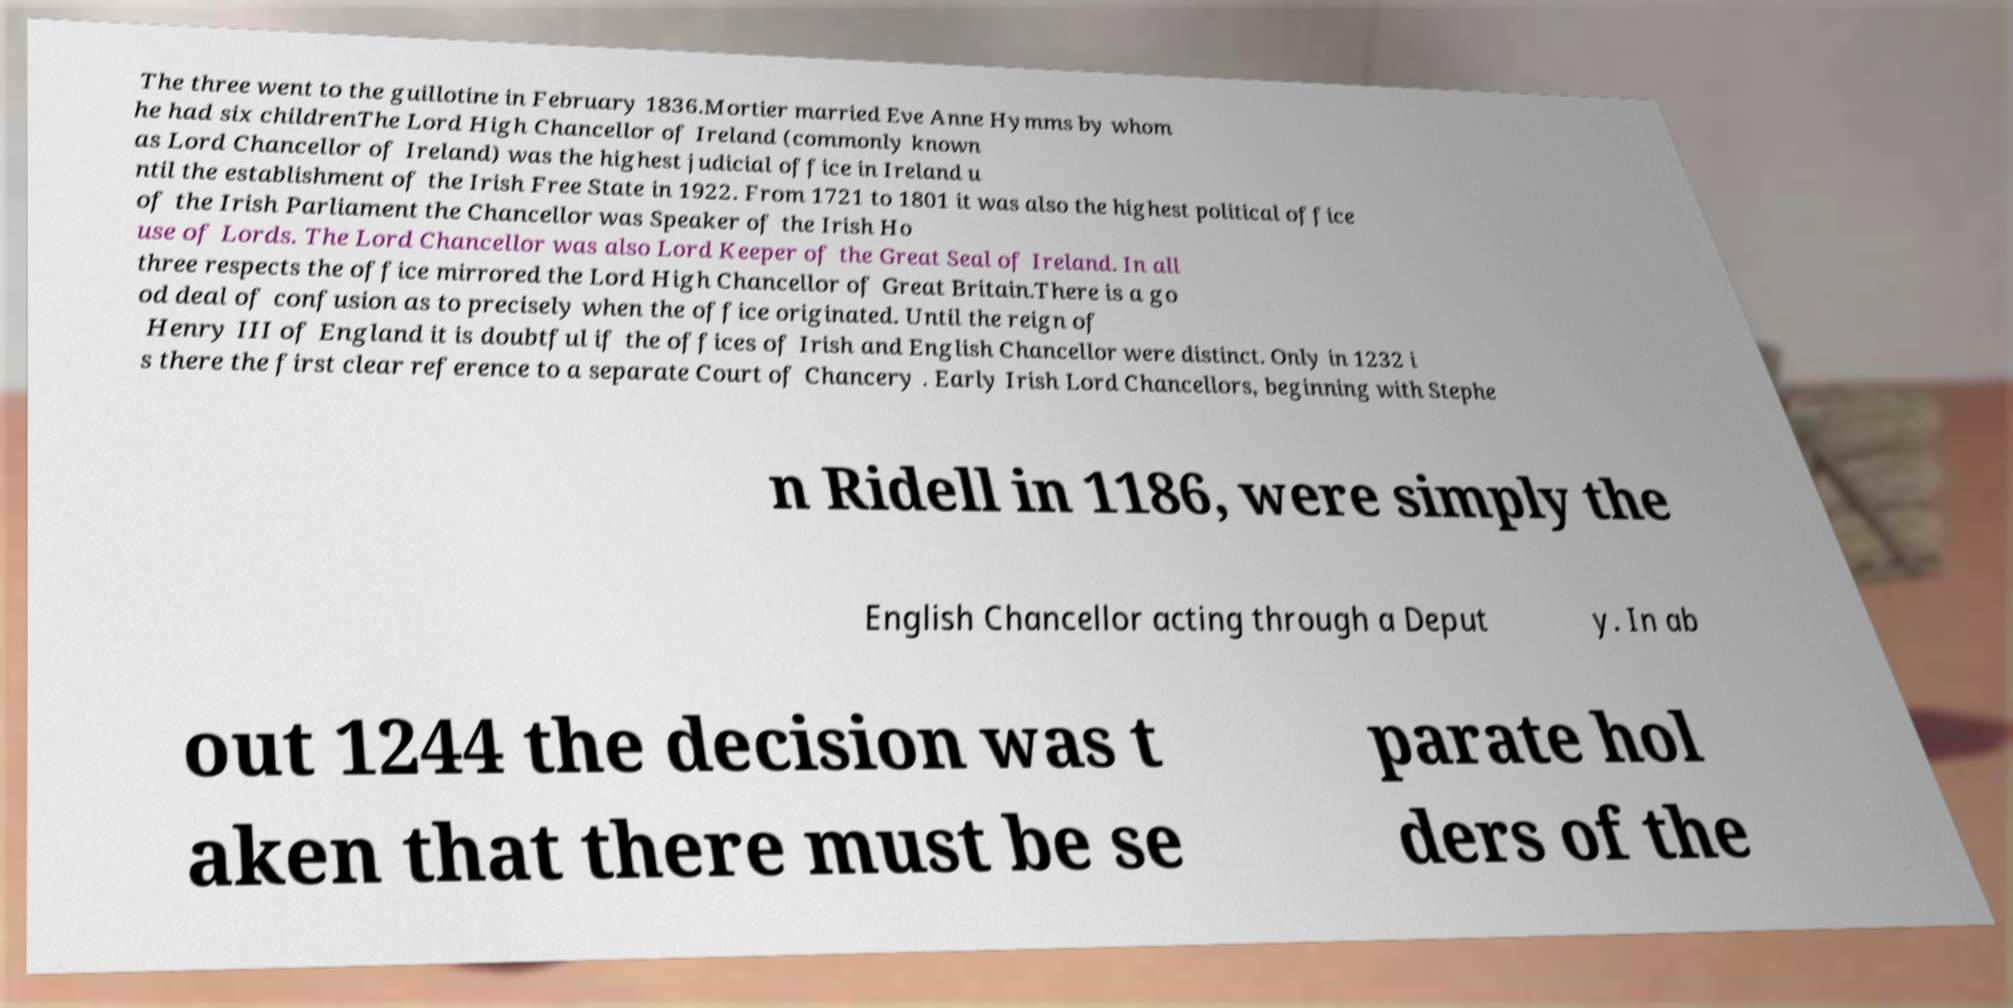For documentation purposes, I need the text within this image transcribed. Could you provide that? The three went to the guillotine in February 1836.Mortier married Eve Anne Hymms by whom he had six childrenThe Lord High Chancellor of Ireland (commonly known as Lord Chancellor of Ireland) was the highest judicial office in Ireland u ntil the establishment of the Irish Free State in 1922. From 1721 to 1801 it was also the highest political office of the Irish Parliament the Chancellor was Speaker of the Irish Ho use of Lords. The Lord Chancellor was also Lord Keeper of the Great Seal of Ireland. In all three respects the office mirrored the Lord High Chancellor of Great Britain.There is a go od deal of confusion as to precisely when the office originated. Until the reign of Henry III of England it is doubtful if the offices of Irish and English Chancellor were distinct. Only in 1232 i s there the first clear reference to a separate Court of Chancery . Early Irish Lord Chancellors, beginning with Stephe n Ridell in 1186, were simply the English Chancellor acting through a Deput y. In ab out 1244 the decision was t aken that there must be se parate hol ders of the 